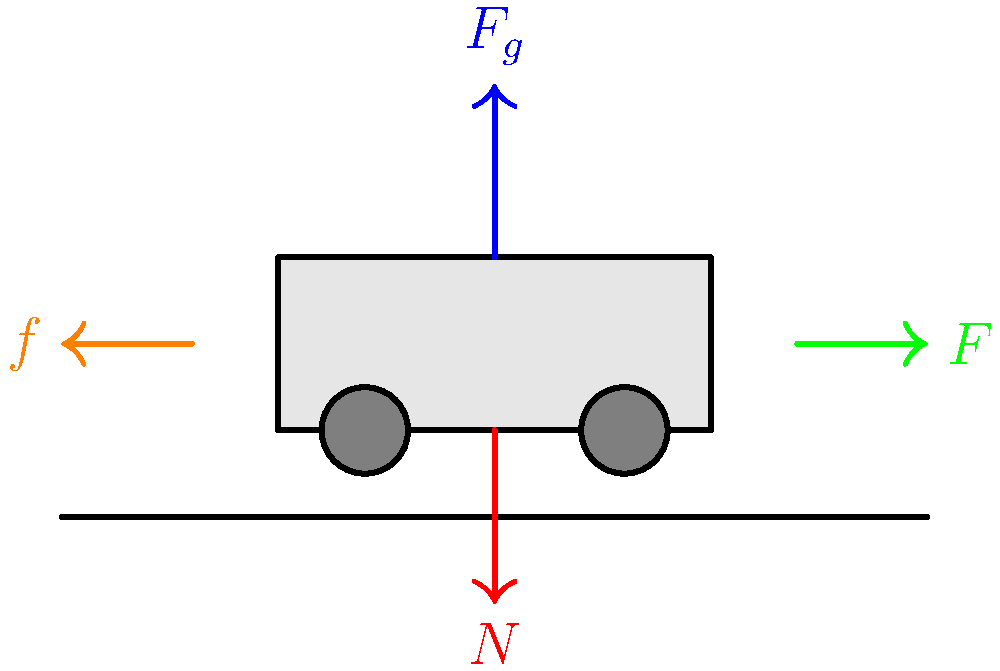During a royal procession, Her Majesty's carriage moves at a constant velocity along a flat road. If the total mass of the carriage (including passengers) is 2500 kg, and the coefficient of rolling friction is 0.02, calculate the force $F$ required to maintain this constant velocity. Assume $g = 9.8 \text{ m/s}^2$. Let's approach this step-by-step, keeping in mind the grandeur of the royal procession:

1) First, we need to identify the forces acting on the carriage:
   - Gravitational force ($F_g$) acting downwards
   - Normal force ($N$) from the road acting upwards
   - Applied force ($F$) moving the carriage forward
   - Frictional force ($f$) opposing the motion

2) Since the carriage is moving at constant velocity, we know that the net force is zero. This means the applied force $F$ must be equal to the frictional force $f$.

3) The gravitational force is given by:
   $F_g = mg = 2500 \text{ kg} \times 9.8 \text{ m/s}^2 = 24500 \text{ N}$

4) Since the carriage is not moving vertically, the normal force $N$ must be equal to the gravitational force:
   $N = F_g = 24500 \text{ N}$

5) For rolling friction, the frictional force is given by:
   $f = \mu N$
   where $\mu$ is the coefficient of rolling friction.

6) Substituting the values:
   $f = 0.02 \times 24500 \text{ N} = 490 \text{ N}$

7) Since the applied force $F$ must equal the frictional force $f$ for constant velocity:
   $F = f = 490 \text{ N}$

Thus, a force of 490 N is required to maintain the constant velocity of Her Majesty's carriage during the royal procession.
Answer: 490 N 